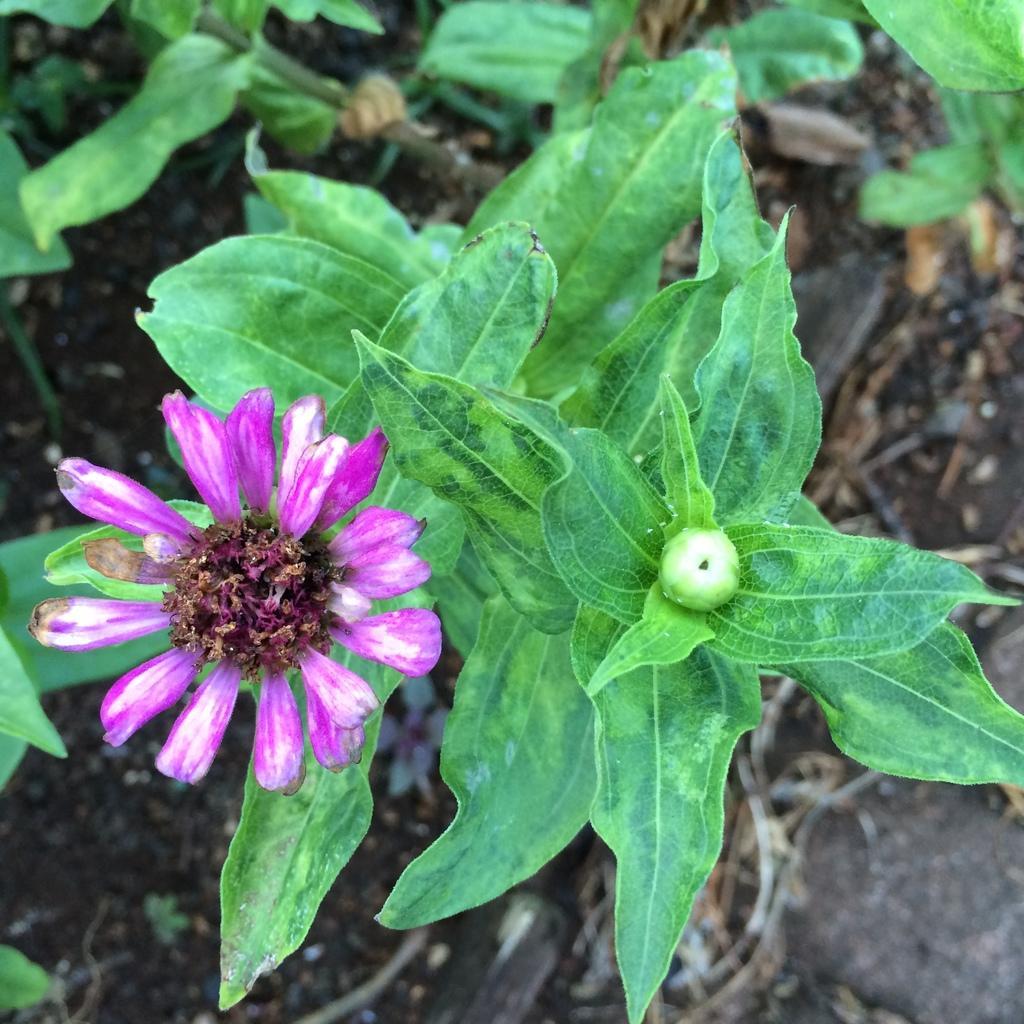Describe this image in one or two sentences. In this image we can see a flower, a bud, also we can see plants, and the background is blurred. 